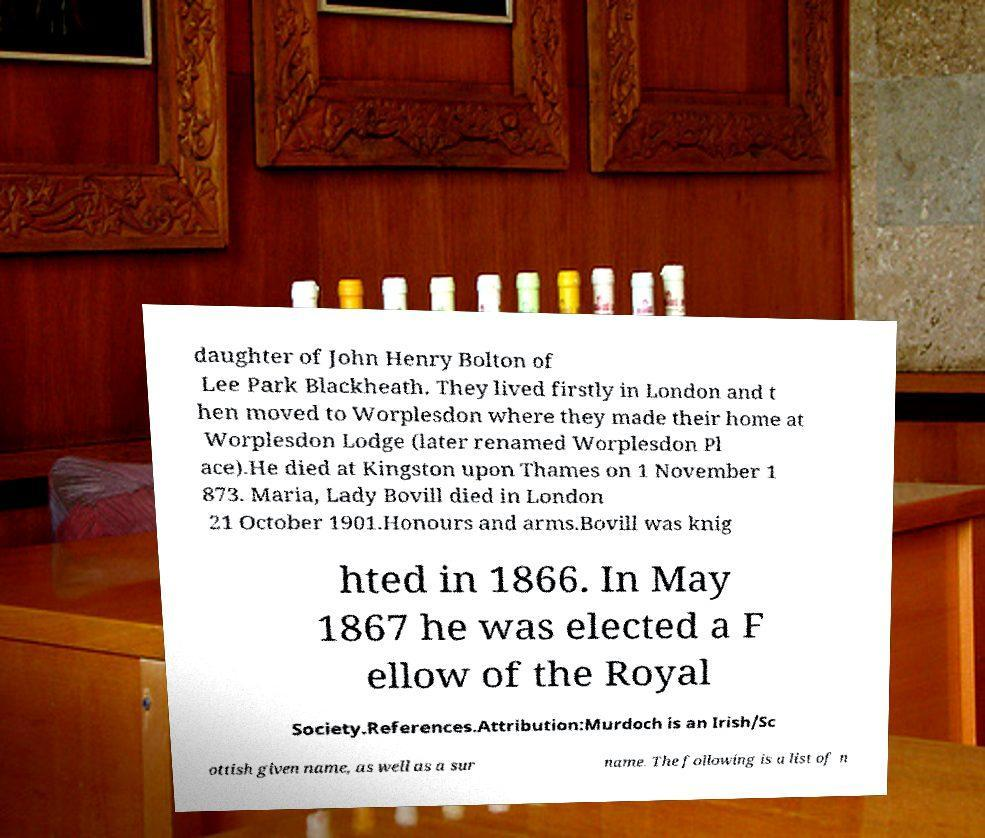Could you assist in decoding the text presented in this image and type it out clearly? daughter of John Henry Bolton of Lee Park Blackheath. They lived firstly in London and t hen moved to Worplesdon where they made their home at Worplesdon Lodge (later renamed Worplesdon Pl ace).He died at Kingston upon Thames on 1 November 1 873. Maria, Lady Bovill died in London 21 October 1901.Honours and arms.Bovill was knig hted in 1866. In May 1867 he was elected a F ellow of the Royal Society.References.Attribution:Murdoch is an Irish/Sc ottish given name, as well as a sur name. The following is a list of n 